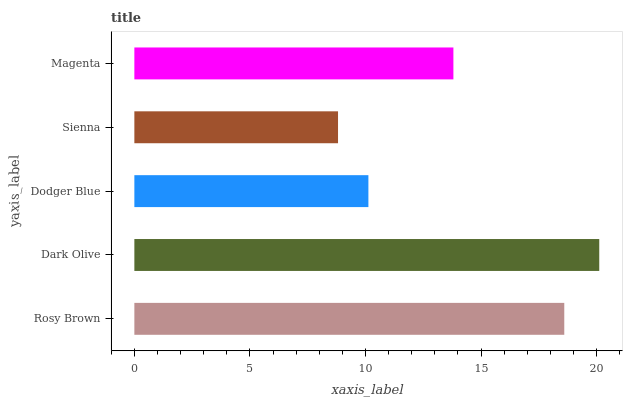Is Sienna the minimum?
Answer yes or no. Yes. Is Dark Olive the maximum?
Answer yes or no. Yes. Is Dodger Blue the minimum?
Answer yes or no. No. Is Dodger Blue the maximum?
Answer yes or no. No. Is Dark Olive greater than Dodger Blue?
Answer yes or no. Yes. Is Dodger Blue less than Dark Olive?
Answer yes or no. Yes. Is Dodger Blue greater than Dark Olive?
Answer yes or no. No. Is Dark Olive less than Dodger Blue?
Answer yes or no. No. Is Magenta the high median?
Answer yes or no. Yes. Is Magenta the low median?
Answer yes or no. Yes. Is Dark Olive the high median?
Answer yes or no. No. Is Rosy Brown the low median?
Answer yes or no. No. 